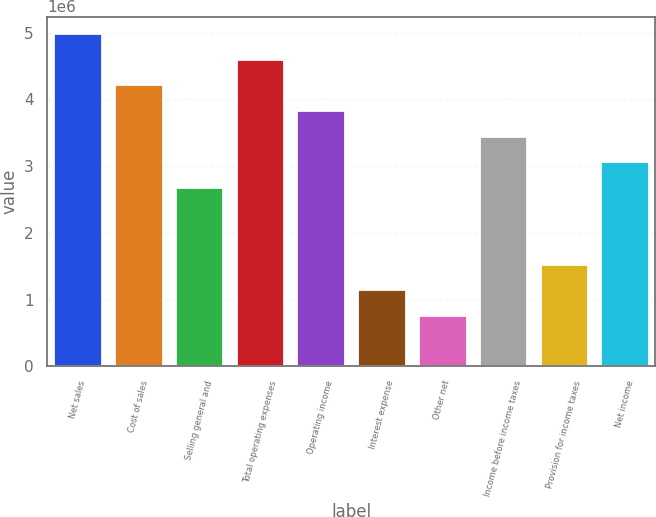<chart> <loc_0><loc_0><loc_500><loc_500><bar_chart><fcel>Net sales<fcel>Cost of sales<fcel>Selling general and<fcel>Total operating expenses<fcel>Operating income<fcel>Interest expense<fcel>Other net<fcel>Income before income taxes<fcel>Provision for income taxes<fcel>Net income<nl><fcel>4.99211e+06<fcel>4.2241e+06<fcel>2.68806e+06<fcel>4.6081e+06<fcel>3.84009e+06<fcel>1.15203e+06<fcel>768019<fcel>3.45608e+06<fcel>1.53604e+06<fcel>3.07207e+06<nl></chart> 